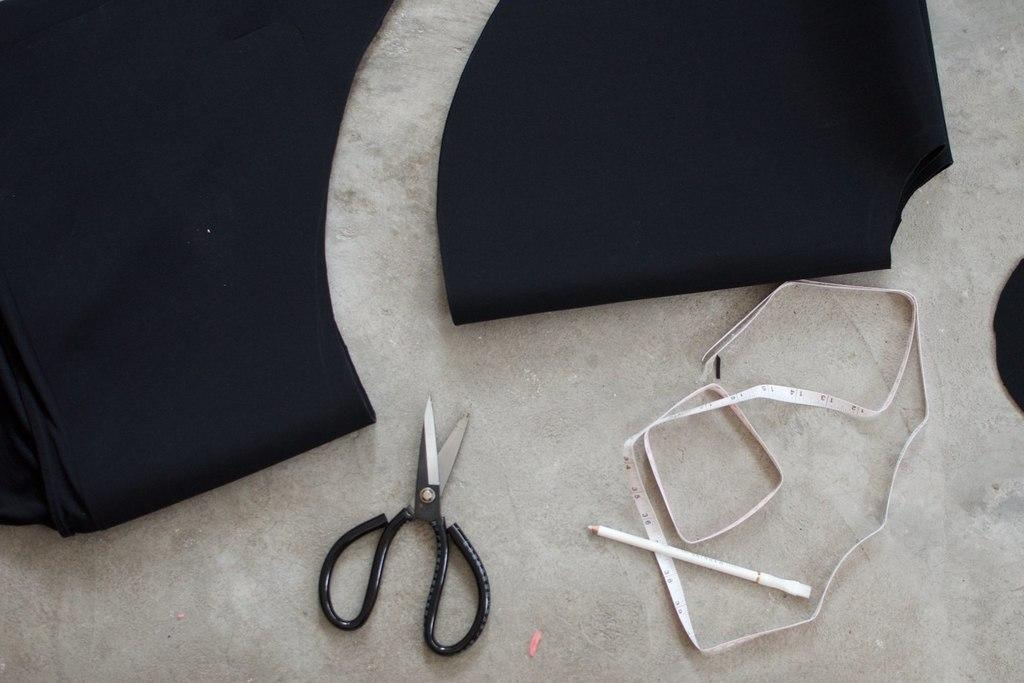What type of stationery item is present in the image? There is a pencil in the image. What tool is used for measuring in the image? There is a measuring tape in the image. What object is used for cutting in the image? There are scissors in the image. What can be seen on the floor in the image? There are clothes on the floor in the image. What type of carriage is visible in the image? There is no carriage present in the image. How does the pencil cough in the image? The pencil does not cough in the image; it is an inanimate object. 